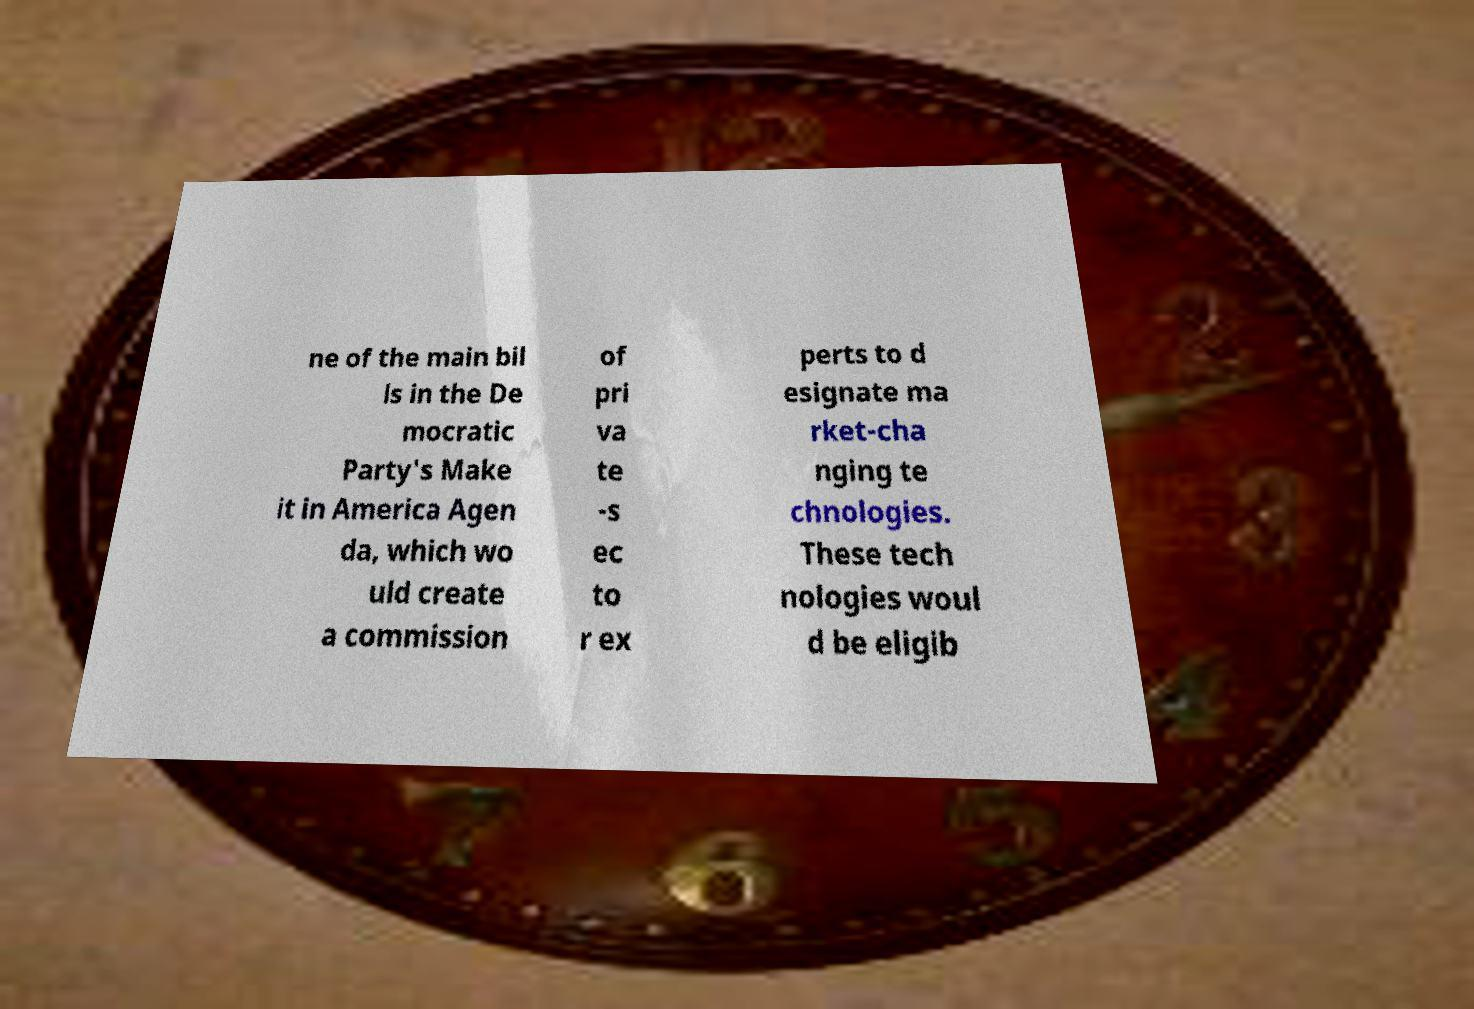Could you assist in decoding the text presented in this image and type it out clearly? ne of the main bil ls in the De mocratic Party's Make it in America Agen da, which wo uld create a commission of pri va te -s ec to r ex perts to d esignate ma rket-cha nging te chnologies. These tech nologies woul d be eligib 